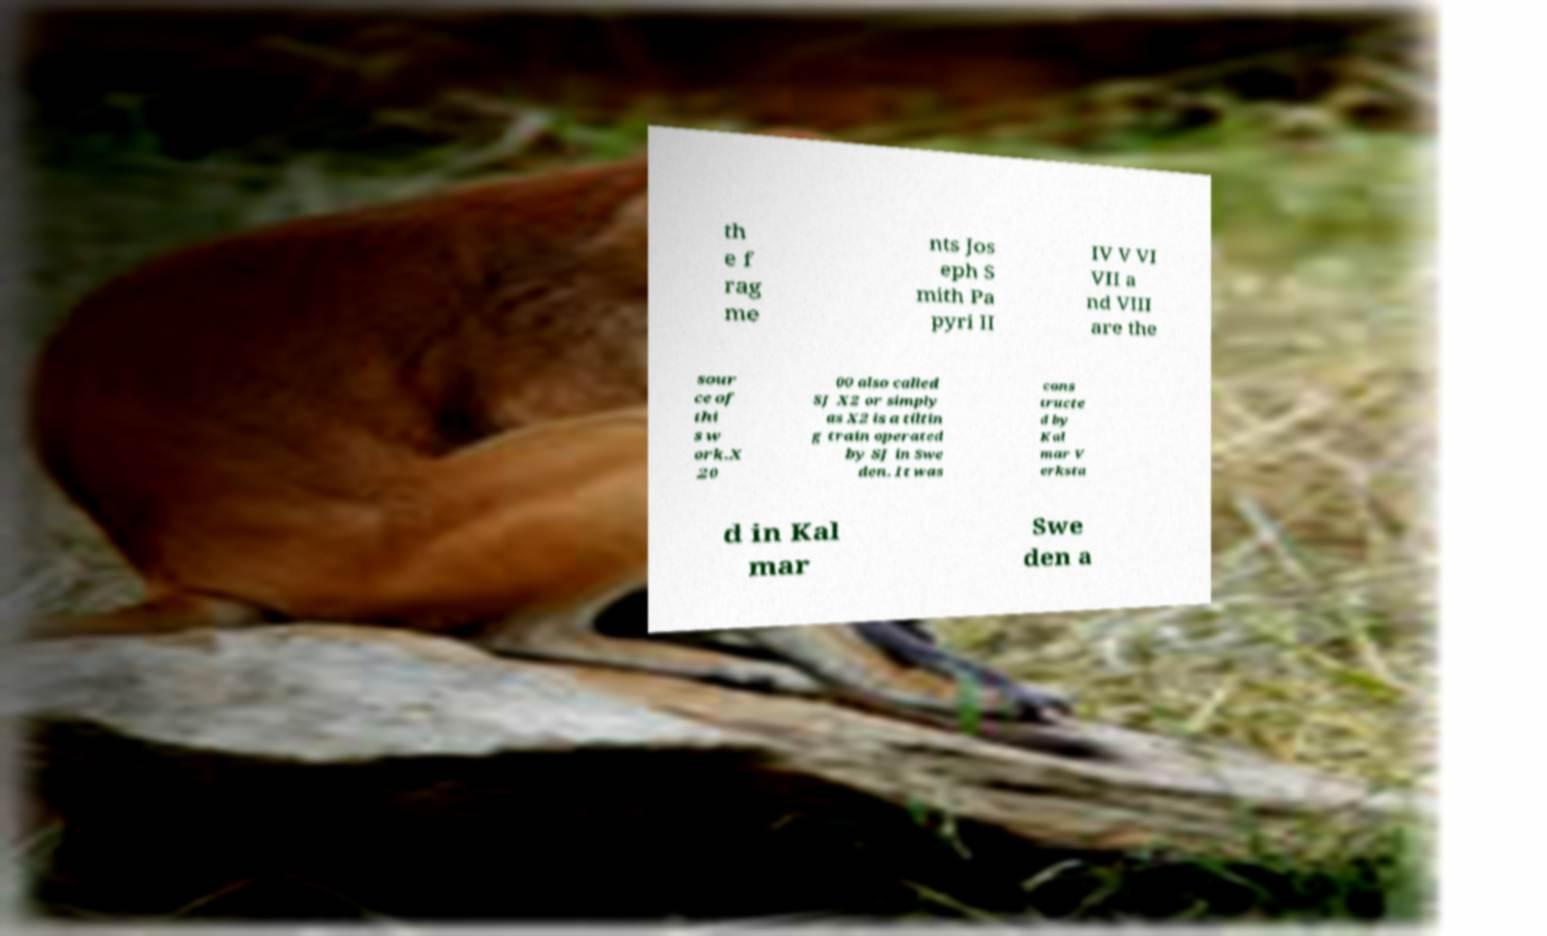Please read and relay the text visible in this image. What does it say? th e f rag me nts Jos eph S mith Pa pyri II IV V VI VII a nd VIII are the sour ce of thi s w ork.X 20 00 also called SJ X2 or simply as X2 is a tiltin g train operated by SJ in Swe den. It was cons tructe d by Kal mar V erksta d in Kal mar Swe den a 